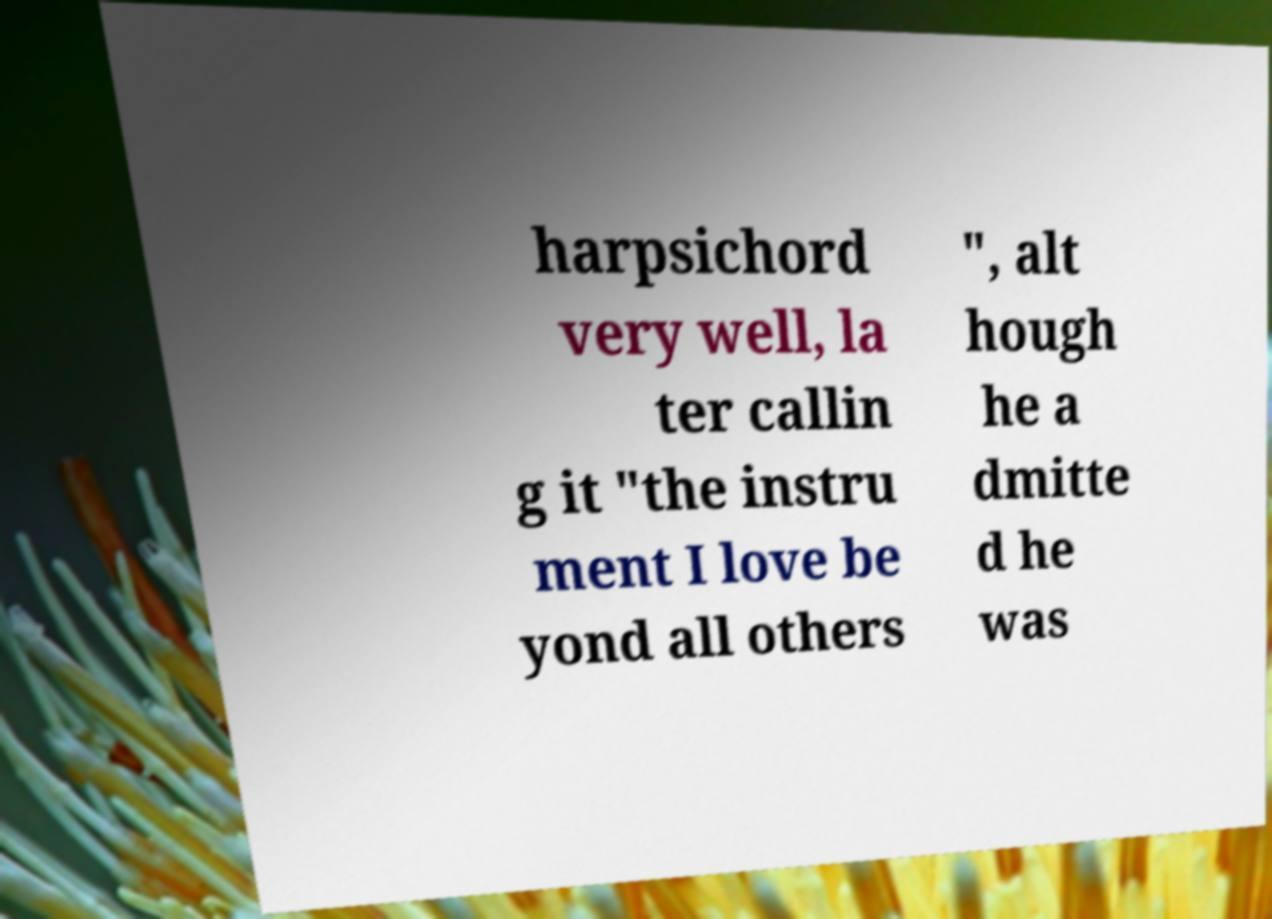Could you extract and type out the text from this image? harpsichord very well, la ter callin g it "the instru ment I love be yond all others ", alt hough he a dmitte d he was 